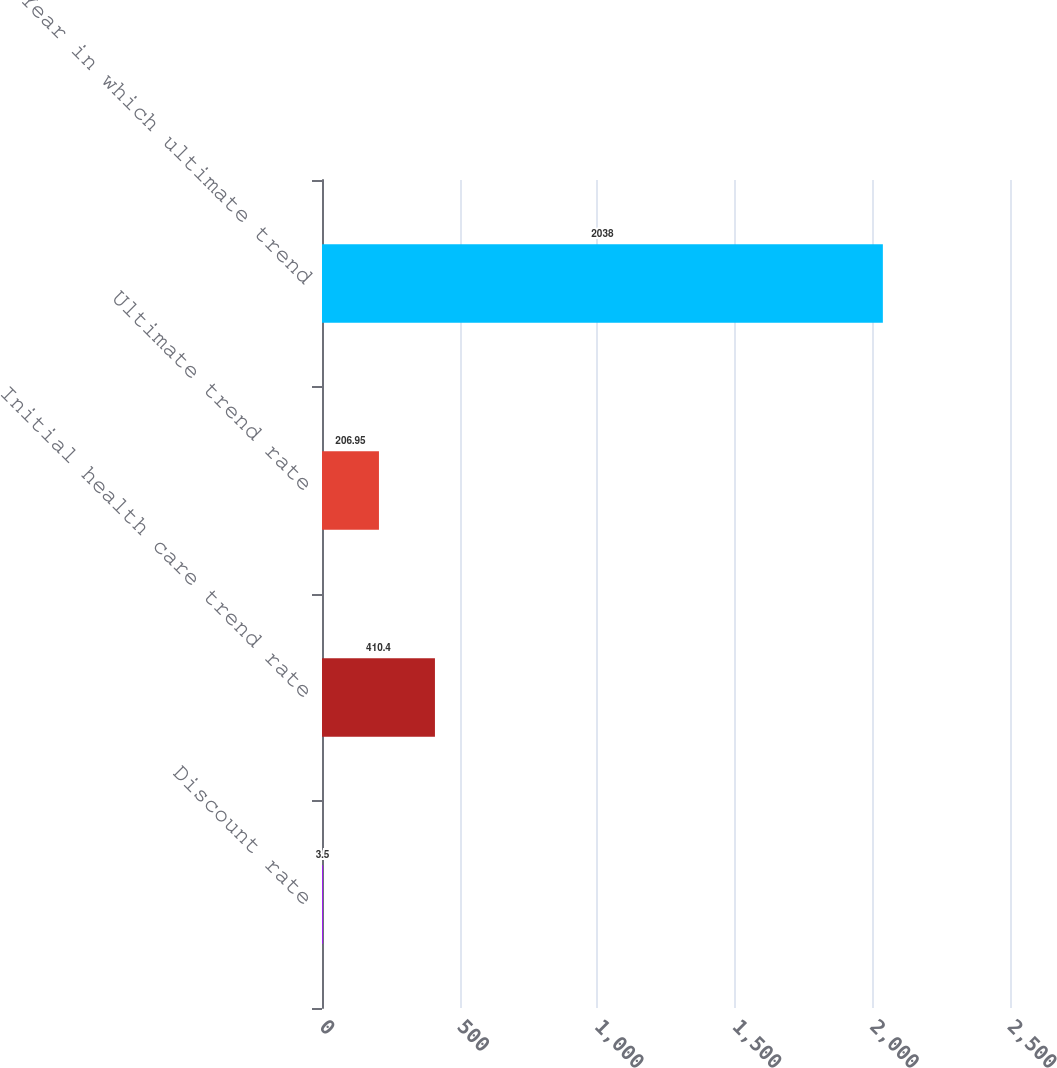Convert chart to OTSL. <chart><loc_0><loc_0><loc_500><loc_500><bar_chart><fcel>Discount rate<fcel>Initial health care trend rate<fcel>Ultimate trend rate<fcel>Year in which ultimate trend<nl><fcel>3.5<fcel>410.4<fcel>206.95<fcel>2038<nl></chart> 